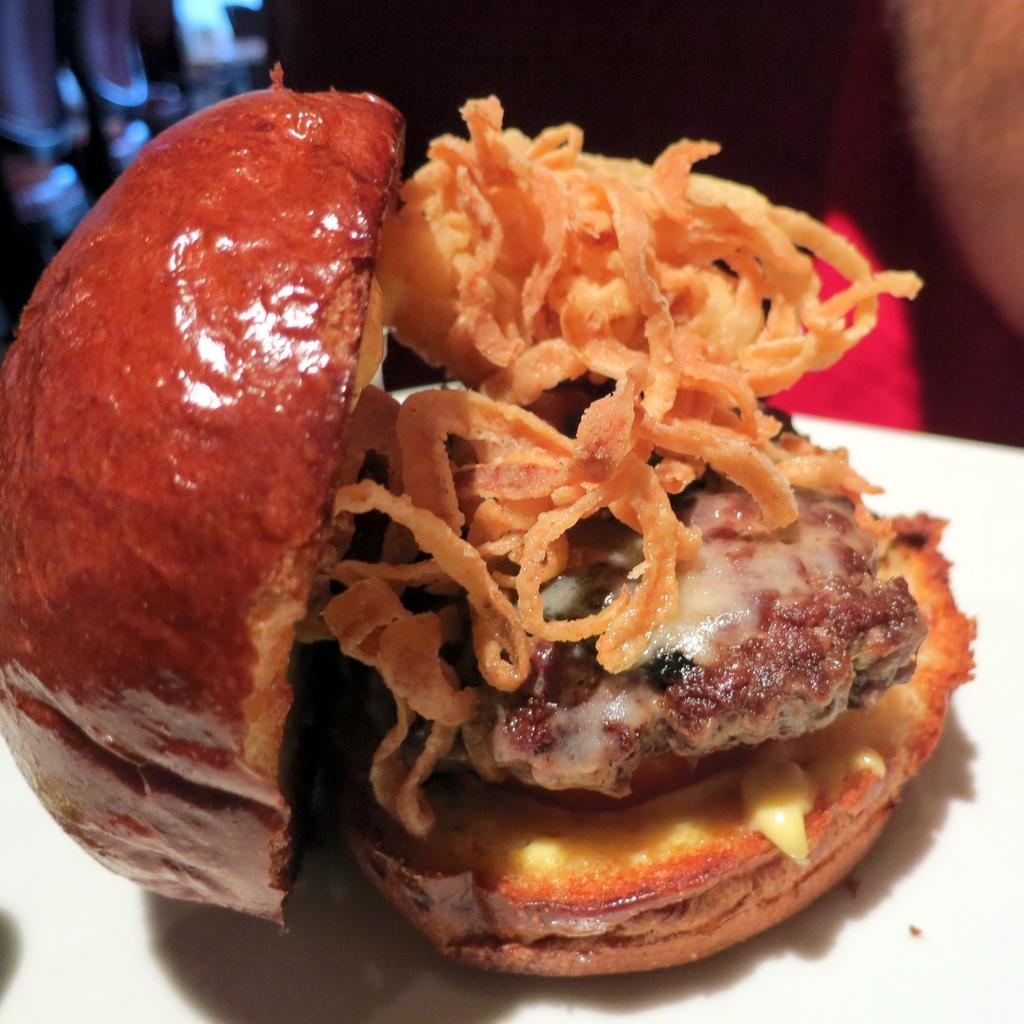How would you summarize this image in a sentence or two? In the center of the image we can see burger on the table. 